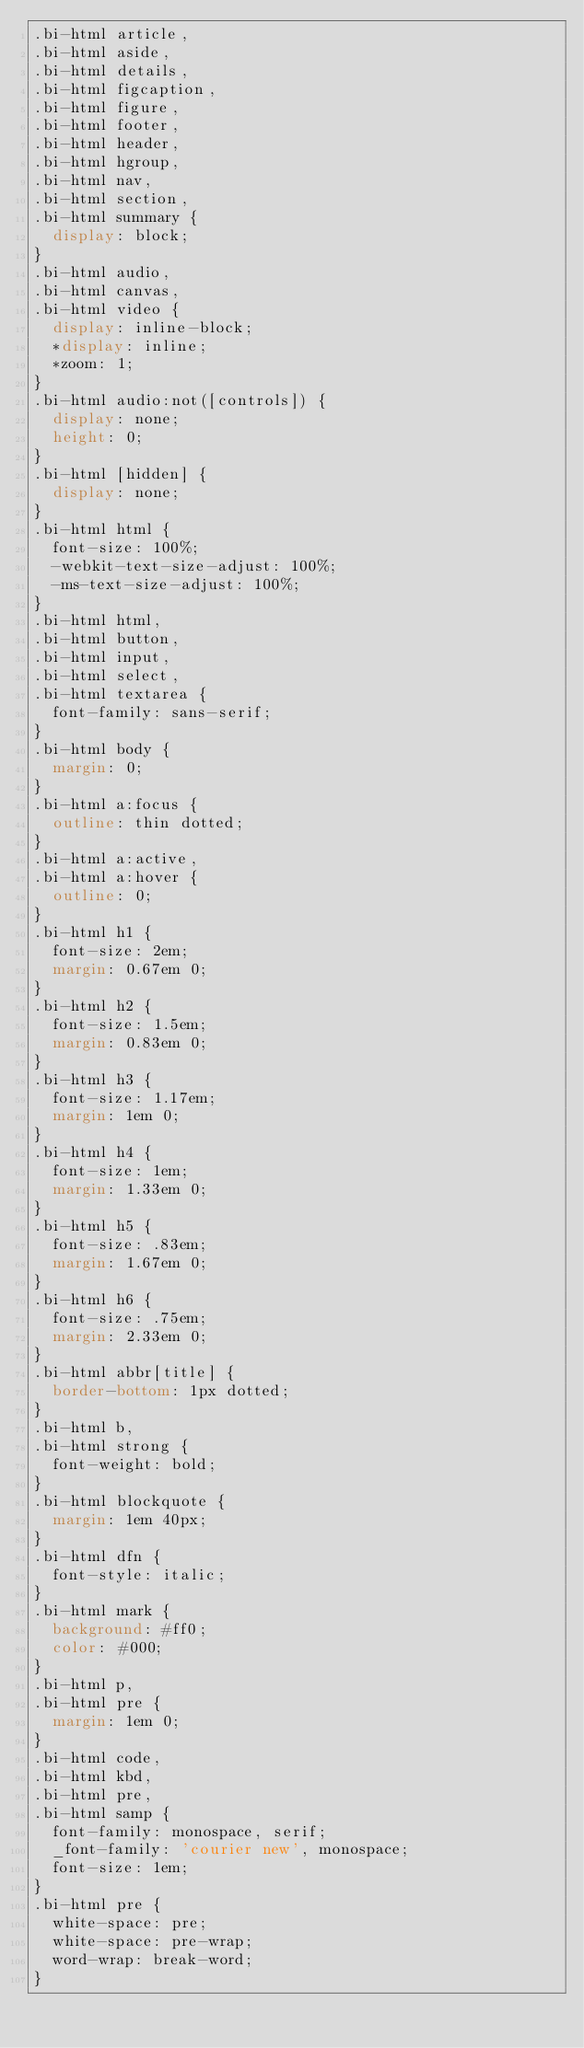<code> <loc_0><loc_0><loc_500><loc_500><_CSS_>.bi-html article,
.bi-html aside,
.bi-html details,
.bi-html figcaption,
.bi-html figure,
.bi-html footer,
.bi-html header,
.bi-html hgroup,
.bi-html nav,
.bi-html section,
.bi-html summary {
  display: block;
}
.bi-html audio,
.bi-html canvas,
.bi-html video {
  display: inline-block;
  *display: inline;
  *zoom: 1;
}
.bi-html audio:not([controls]) {
  display: none;
  height: 0;
}
.bi-html [hidden] {
  display: none;
}
.bi-html html {
  font-size: 100%;
  -webkit-text-size-adjust: 100%;
  -ms-text-size-adjust: 100%;
}
.bi-html html,
.bi-html button,
.bi-html input,
.bi-html select,
.bi-html textarea {
  font-family: sans-serif;
}
.bi-html body {
  margin: 0;
}
.bi-html a:focus {
  outline: thin dotted;
}
.bi-html a:active,
.bi-html a:hover {
  outline: 0;
}
.bi-html h1 {
  font-size: 2em;
  margin: 0.67em 0;
}
.bi-html h2 {
  font-size: 1.5em;
  margin: 0.83em 0;
}
.bi-html h3 {
  font-size: 1.17em;
  margin: 1em 0;
}
.bi-html h4 {
  font-size: 1em;
  margin: 1.33em 0;
}
.bi-html h5 {
  font-size: .83em;
  margin: 1.67em 0;
}
.bi-html h6 {
  font-size: .75em;
  margin: 2.33em 0;
}
.bi-html abbr[title] {
  border-bottom: 1px dotted;
}
.bi-html b,
.bi-html strong {
  font-weight: bold;
}
.bi-html blockquote {
  margin: 1em 40px;
}
.bi-html dfn {
  font-style: italic;
}
.bi-html mark {
  background: #ff0;
  color: #000;
}
.bi-html p,
.bi-html pre {
  margin: 1em 0;
}
.bi-html code,
.bi-html kbd,
.bi-html pre,
.bi-html samp {
  font-family: monospace, serif;
  _font-family: 'courier new', monospace;
  font-size: 1em;
}
.bi-html pre {
  white-space: pre;
  white-space: pre-wrap;
  word-wrap: break-word;
}</code> 